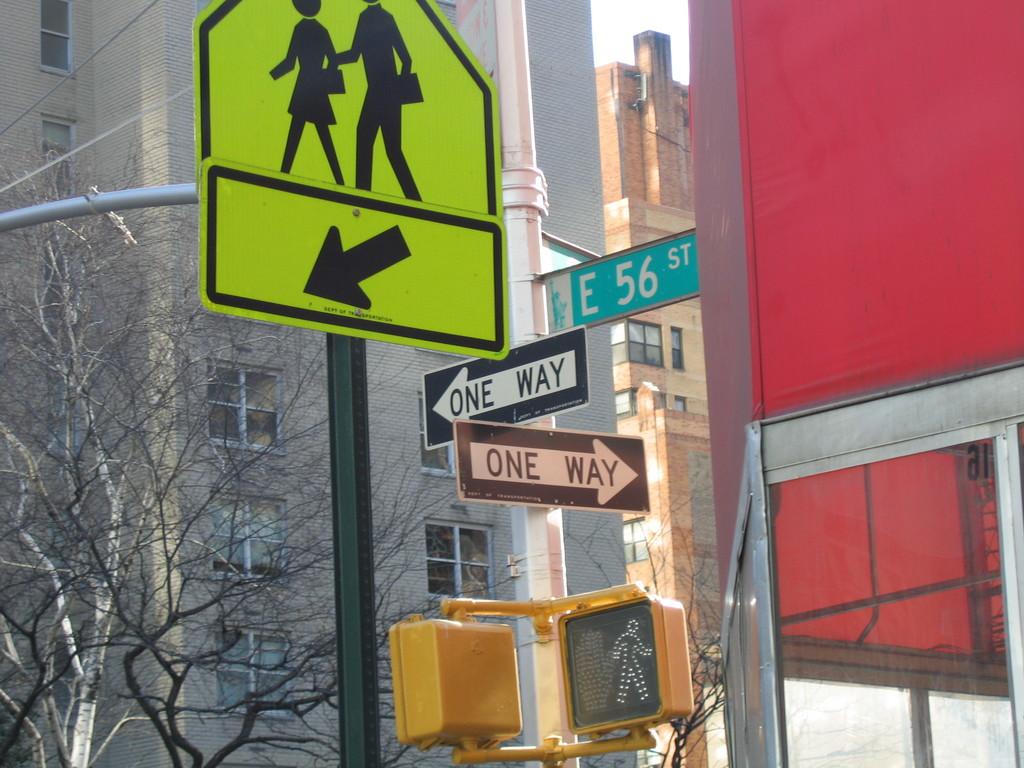What street is this?
Make the answer very short. E 56 st. What types of streets are these?
Give a very brief answer. One way. 